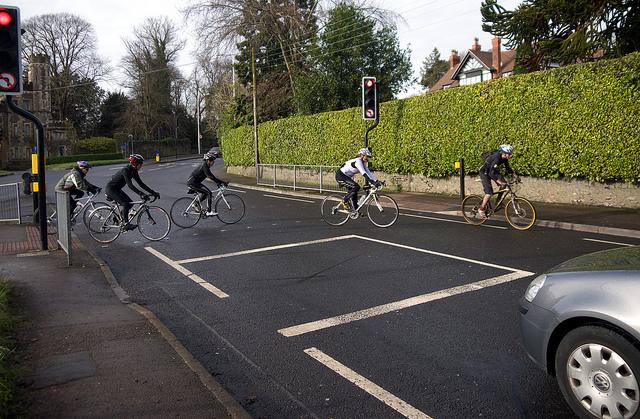What color is the car?
Quick response, please. Silver. What are the people doing?
Answer briefly. Riding bikes. Is the ground wet?
Concise answer only. Yes. 